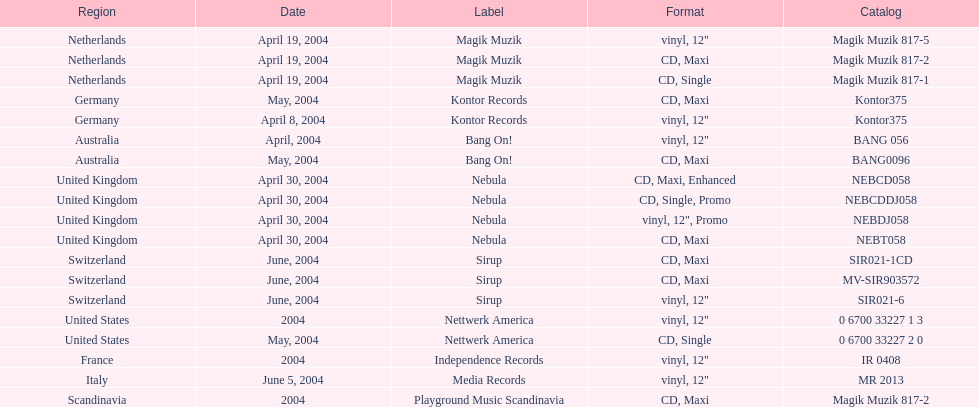Which geographical location is at the top of the list? Netherlands. 